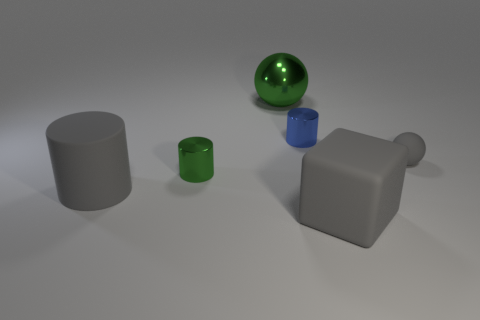Is there a big matte block of the same color as the tiny rubber ball?
Make the answer very short. Yes. What color is the sphere that is the same size as the gray rubber cylinder?
Ensure brevity in your answer.  Green. There is a big gray object to the right of the tiny object that is behind the tiny object that is right of the large rubber cube; what is its shape?
Offer a terse response. Cube. How many small metallic cylinders are left of the matte thing on the left side of the green cylinder?
Give a very brief answer. 0. There is a green object behind the tiny ball; is it the same shape as the gray rubber object that is to the right of the gray rubber block?
Give a very brief answer. Yes. How many blue objects are on the left side of the green metallic sphere?
Provide a succinct answer. 0. Is the big thing behind the big gray cylinder made of the same material as the large gray cylinder?
Provide a succinct answer. No. What color is the other metallic thing that is the same shape as the tiny blue object?
Keep it short and to the point. Green. The blue thing is what shape?
Provide a short and direct response. Cylinder. How many objects are either tiny metallic cylinders or large red matte cylinders?
Offer a very short reply. 2. 